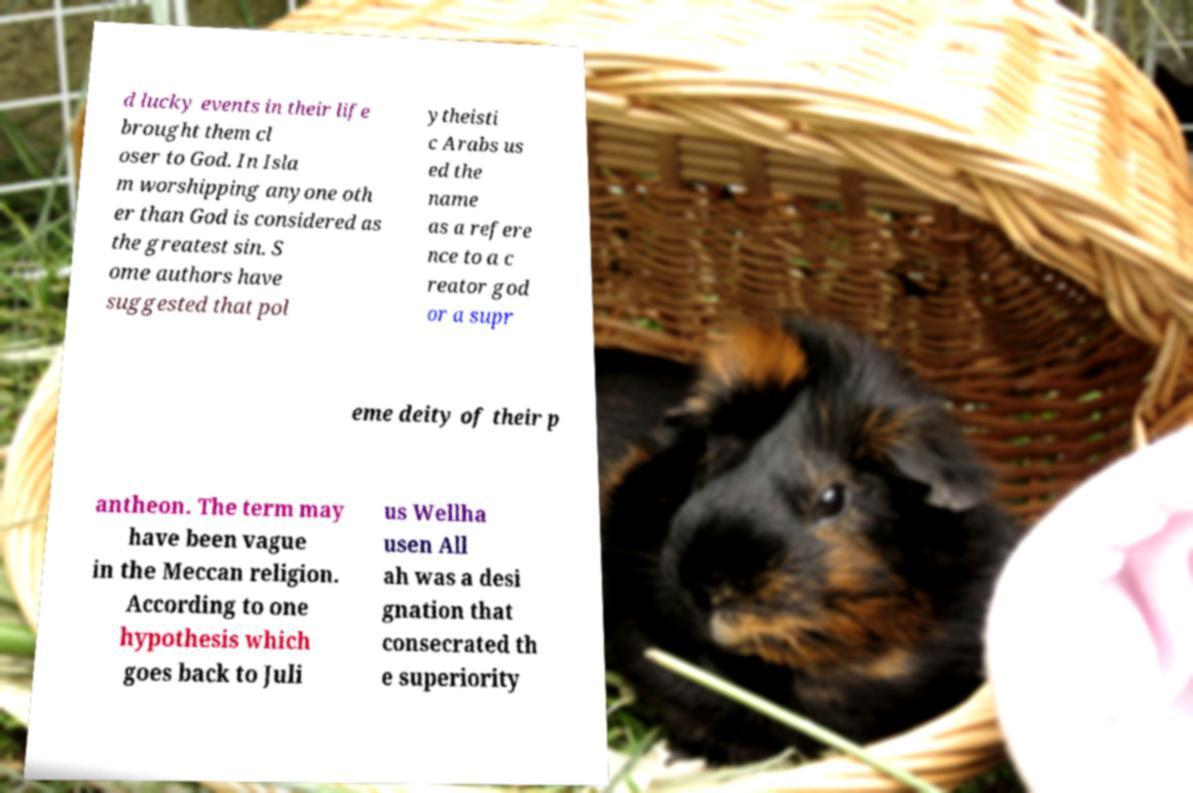For documentation purposes, I need the text within this image transcribed. Could you provide that? d lucky events in their life brought them cl oser to God. In Isla m worshipping anyone oth er than God is considered as the greatest sin. S ome authors have suggested that pol ytheisti c Arabs us ed the name as a refere nce to a c reator god or a supr eme deity of their p antheon. The term may have been vague in the Meccan religion. According to one hypothesis which goes back to Juli us Wellha usen All ah was a desi gnation that consecrated th e superiority 